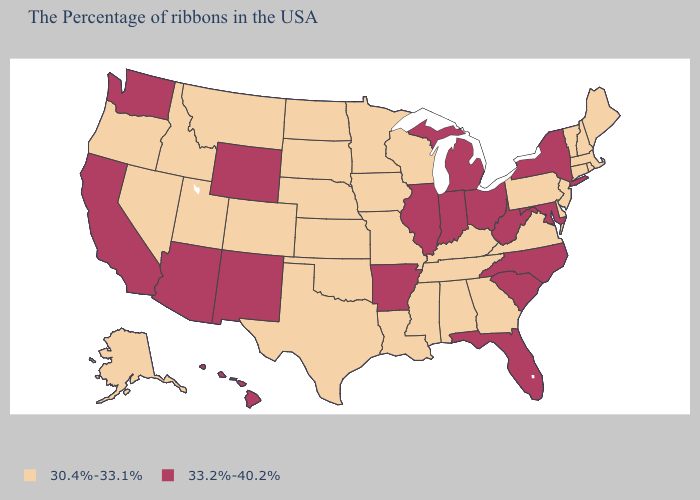Does the first symbol in the legend represent the smallest category?
Concise answer only. Yes. Does Nevada have the highest value in the USA?
Be succinct. No. What is the value of Nevada?
Write a very short answer. 30.4%-33.1%. Is the legend a continuous bar?
Be succinct. No. What is the highest value in the MidWest ?
Write a very short answer. 33.2%-40.2%. Does Maine have the lowest value in the USA?
Short answer required. Yes. What is the value of Tennessee?
Give a very brief answer. 30.4%-33.1%. What is the value of Idaho?
Short answer required. 30.4%-33.1%. Name the states that have a value in the range 33.2%-40.2%?
Quick response, please. New York, Maryland, North Carolina, South Carolina, West Virginia, Ohio, Florida, Michigan, Indiana, Illinois, Arkansas, Wyoming, New Mexico, Arizona, California, Washington, Hawaii. What is the value of Pennsylvania?
Quick response, please. 30.4%-33.1%. Does the first symbol in the legend represent the smallest category?
Keep it brief. Yes. Is the legend a continuous bar?
Give a very brief answer. No. Does Mississippi have the lowest value in the South?
Concise answer only. Yes. What is the value of Ohio?
Give a very brief answer. 33.2%-40.2%. Which states have the lowest value in the MidWest?
Give a very brief answer. Wisconsin, Missouri, Minnesota, Iowa, Kansas, Nebraska, South Dakota, North Dakota. 